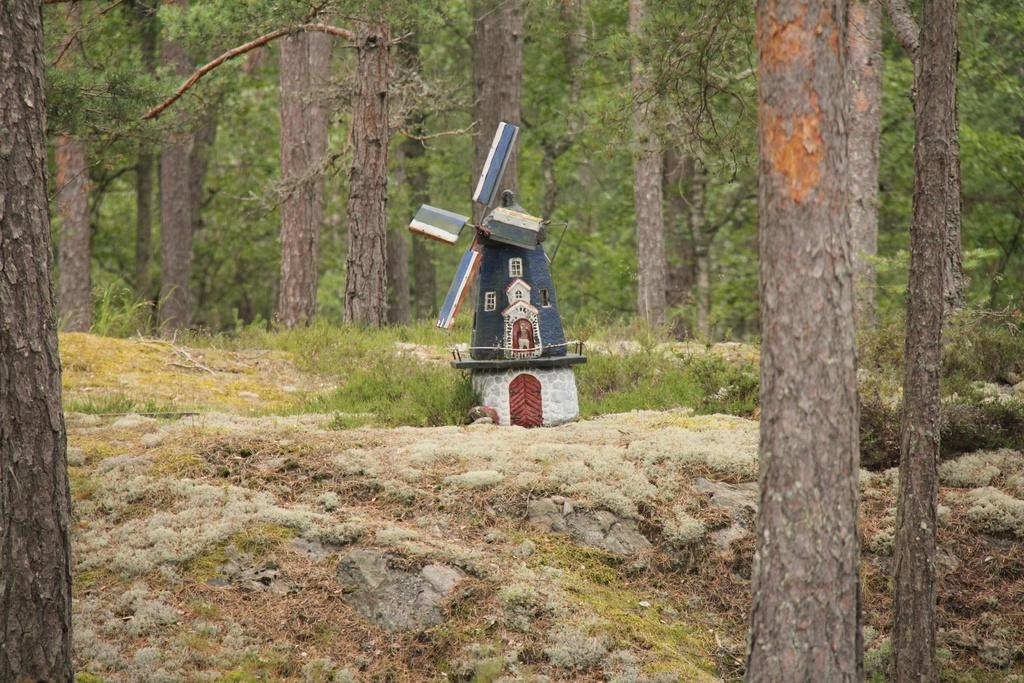What object is placed on the ground in the image? There is a toy placed on the ground. What type of natural environment is visible in the image? There are trees and grass visible in the image. What additional feature can be seen on the ground in the image? There are rocks in the image. What type of sign can be seen written in chalk on the ground in the image? There is no sign written in chalk on the ground in the image. 